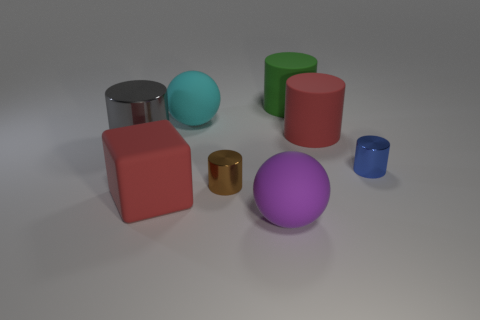What is the shape of the big purple thing that is the same material as the big red cylinder?
Your answer should be very brief. Sphere. How many metal things are big things or large blocks?
Keep it short and to the point. 1. Are there the same number of small brown metal things that are left of the large block and tiny metallic cylinders?
Your answer should be very brief. No. Is the color of the large matte sphere that is behind the brown cylinder the same as the big metallic thing?
Keep it short and to the point. No. There is a big thing that is in front of the tiny blue cylinder and behind the large purple ball; what is its material?
Your answer should be compact. Rubber. Are there any blue cylinders that are behind the blue thing in front of the big metal thing?
Keep it short and to the point. No. Are the cyan thing and the gray object made of the same material?
Keep it short and to the point. No. There is a shiny object that is both behind the tiny brown metallic cylinder and to the right of the cyan ball; what is its shape?
Make the answer very short. Cylinder. There is a red object to the left of the red cylinder that is behind the brown metallic thing; what is its size?
Offer a terse response. Large. How many blue objects have the same shape as the green object?
Give a very brief answer. 1. 